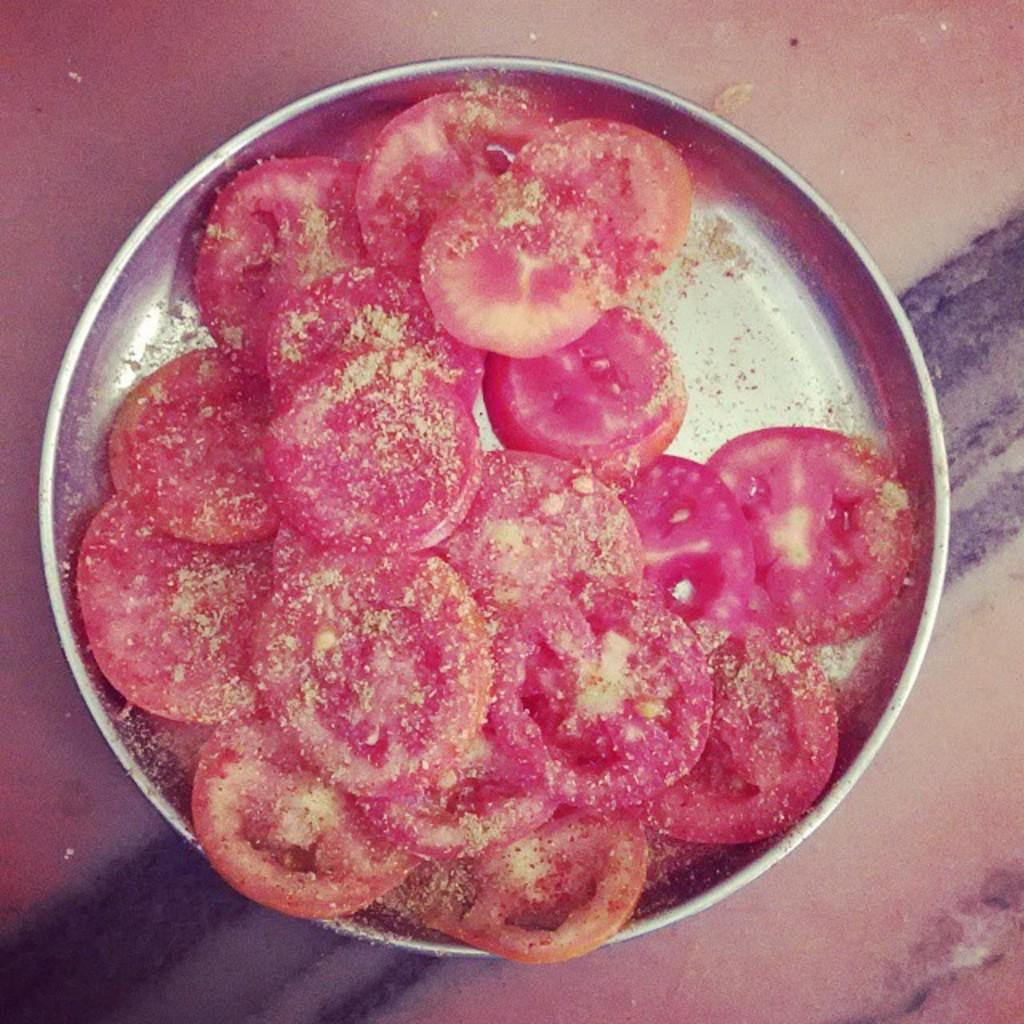What type of food is visible in the image? There are slices of tomatoes in the image. What is on top of the tomato slices? The tomato slices are topped with powder. What is the tomato slices placed on? There is a plate in the image. Where is the plate located? The plate is placed on a surface. What type of hospital equipment can be seen in the image? There is no hospital equipment present in the image; it features tomato slices topped with powder on a plate. How many legs does the table have in the image? There is no table present in the image, so it is not possible to determine the number of legs. 